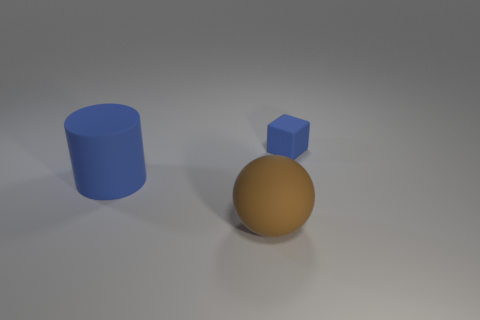Add 1 big green metallic cubes. How many objects exist? 4 Subtract 1 blue cubes. How many objects are left? 2 Subtract all balls. How many objects are left? 2 Subtract all brown blocks. Subtract all purple cylinders. How many blocks are left? 1 Subtract all tiny yellow metallic balls. Subtract all big blue things. How many objects are left? 2 Add 1 large brown objects. How many large brown objects are left? 2 Add 1 large red metal cylinders. How many large red metal cylinders exist? 1 